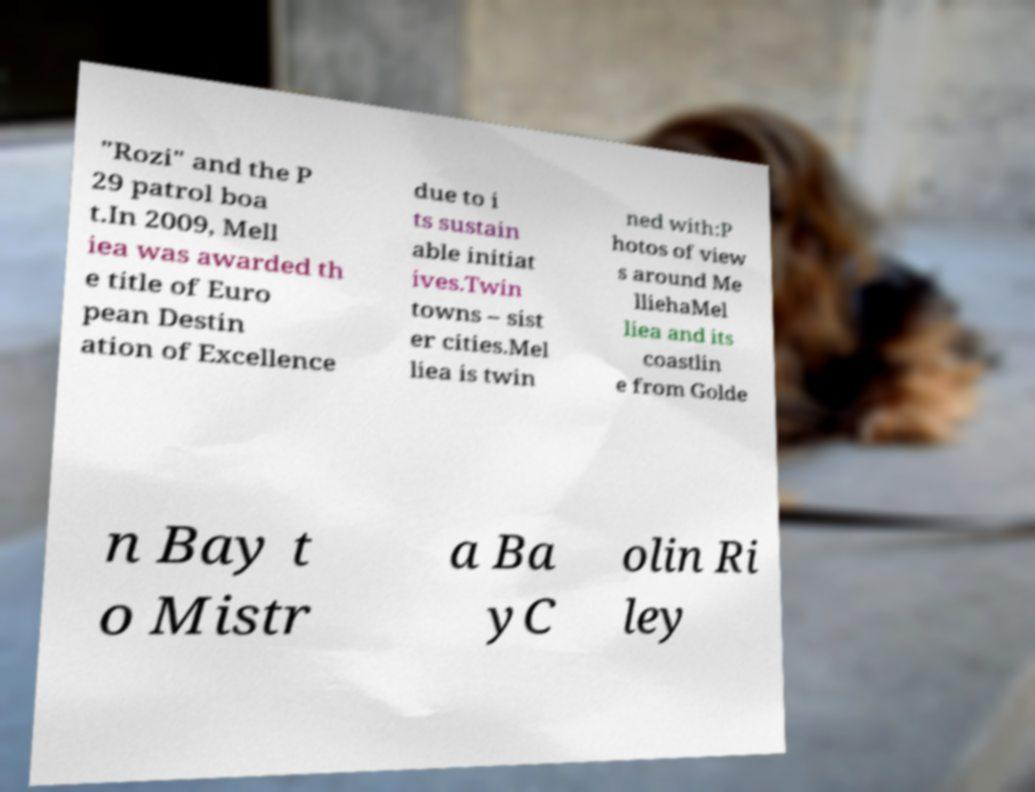Could you assist in decoding the text presented in this image and type it out clearly? "Rozi" and the P 29 patrol boa t.In 2009, Mell iea was awarded th e title of Euro pean Destin ation of Excellence due to i ts sustain able initiat ives.Twin towns – sist er cities.Mel liea is twin ned with:P hotos of view s around Me lliehaMel liea and its coastlin e from Golde n Bay t o Mistr a Ba yC olin Ri ley 